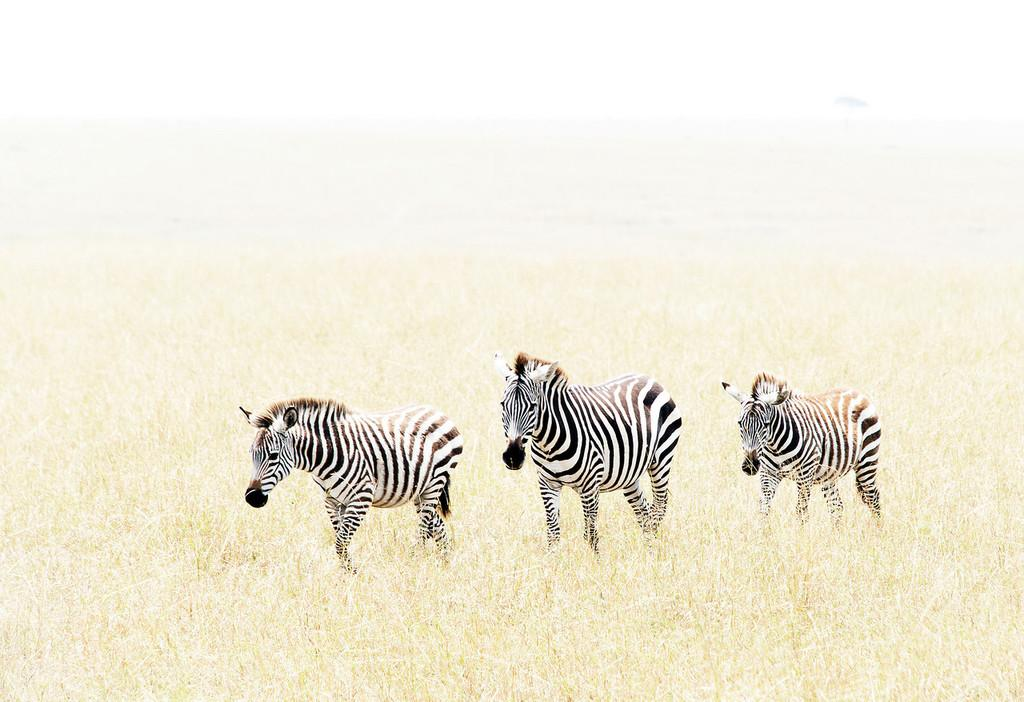What animals are present in the image? There are zebras in the image. What type of vegetation can be seen in the image? There is grass in the image. Can you describe the background of the image? The background of the image is blurry. What grade did the zebras receive for their decision-making skills in the image? There is no indication of any decision-making skills or grades in the image, as it simply features zebras and grass. 